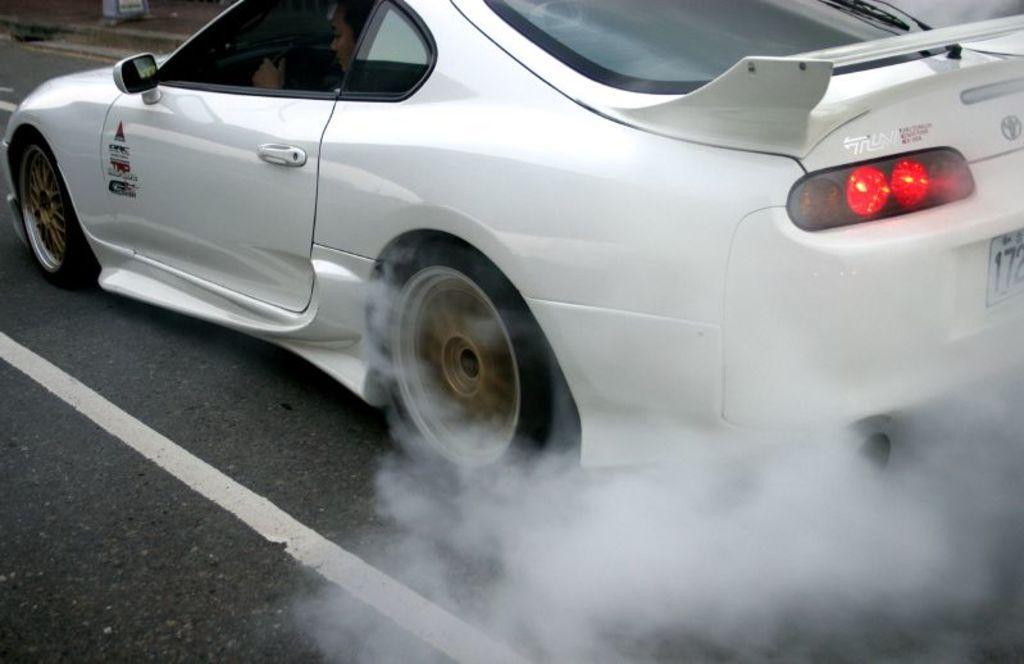Could you give a brief overview of what you see in this image? In this picture we can see a car on the road, smoke and in the background we can see an object on a footpath. 